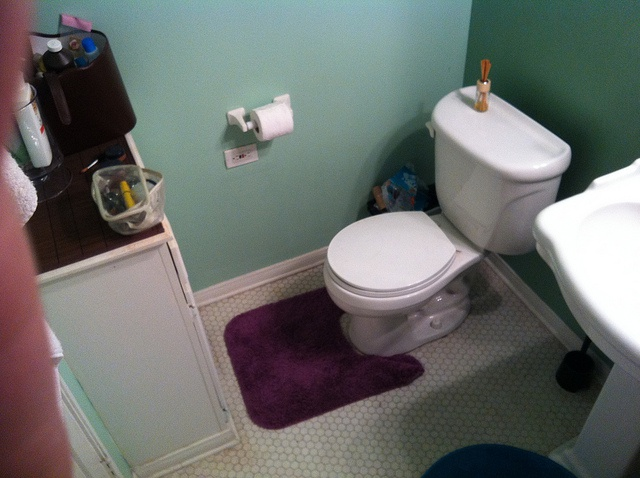Describe the objects in this image and their specific colors. I can see sink in brown, white, gray, black, and purple tones, toilet in brown, lightgray, gray, darkgray, and black tones, bottle in brown, darkgray, gray, and lightgray tones, bottle in brown, black, darkgray, and gray tones, and bottle in brown, black, navy, and gray tones in this image. 